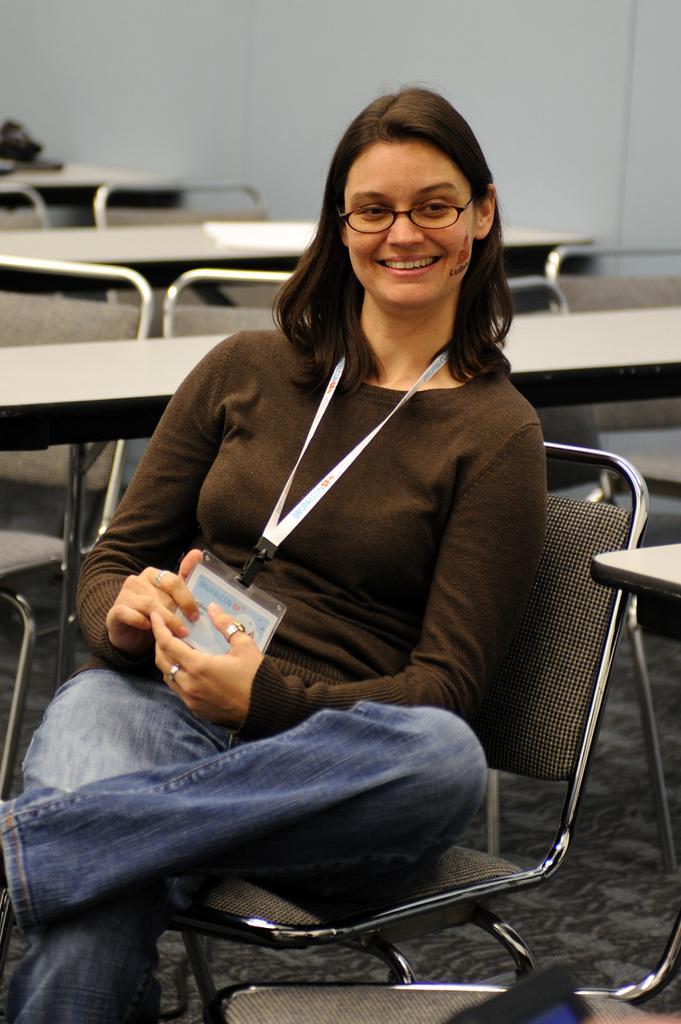Describe this image in one or two sentences. There is a woman who is sitting on the chair. She wear a id card. She is smiling and she has spectacles. This is floor and there are tables. On the background there is a wall. 